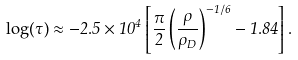Convert formula to latex. <formula><loc_0><loc_0><loc_500><loc_500>\log ( \tau ) \approx - 2 . 5 \times 1 0 ^ { 4 } \left [ \frac { \pi } { 2 } \left ( \frac { \rho } { \rho _ { D } } \right ) ^ { - 1 / 6 } - 1 . 8 4 \right ] .</formula> 